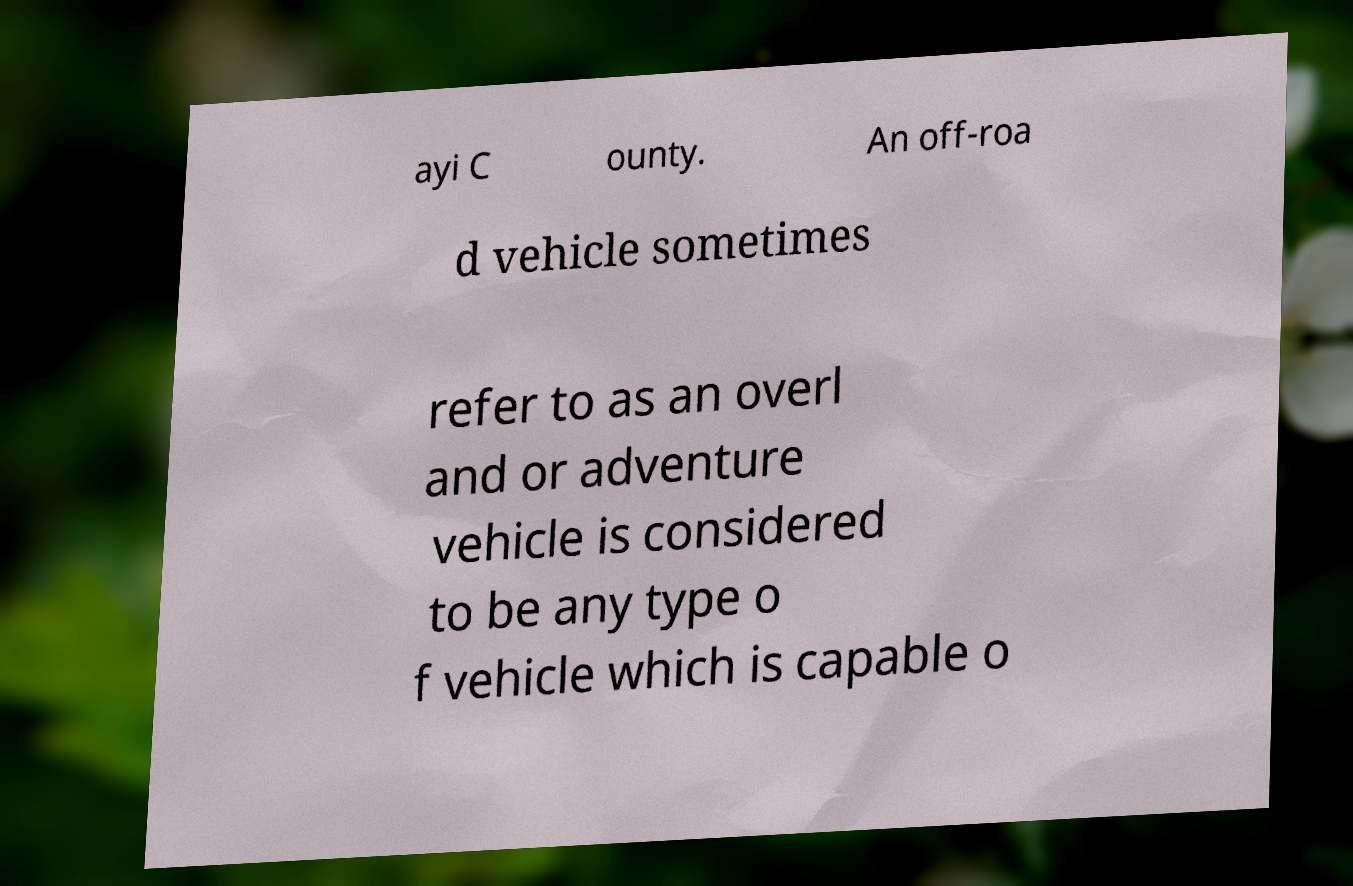There's text embedded in this image that I need extracted. Can you transcribe it verbatim? ayi C ounty. An off-roa d vehicle sometimes refer to as an overl and or adventure vehicle is considered to be any type o f vehicle which is capable o 